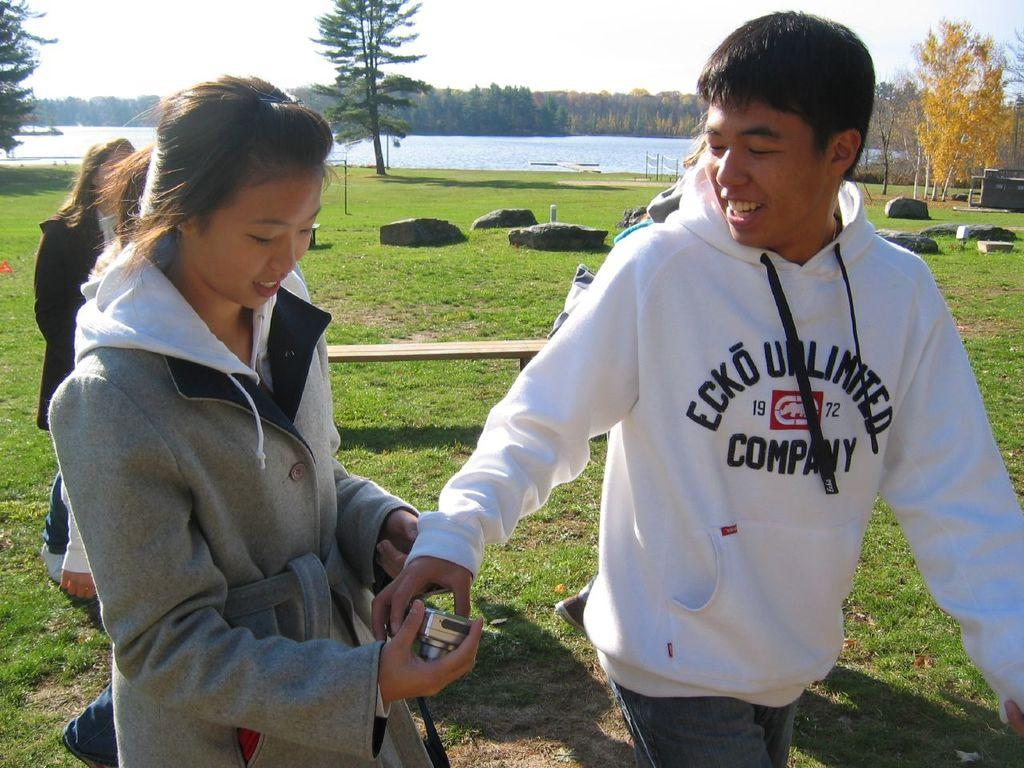<image>
Provide a brief description of the given image. Two people are interacting and the male is wearing an ecko unlimited sweater 